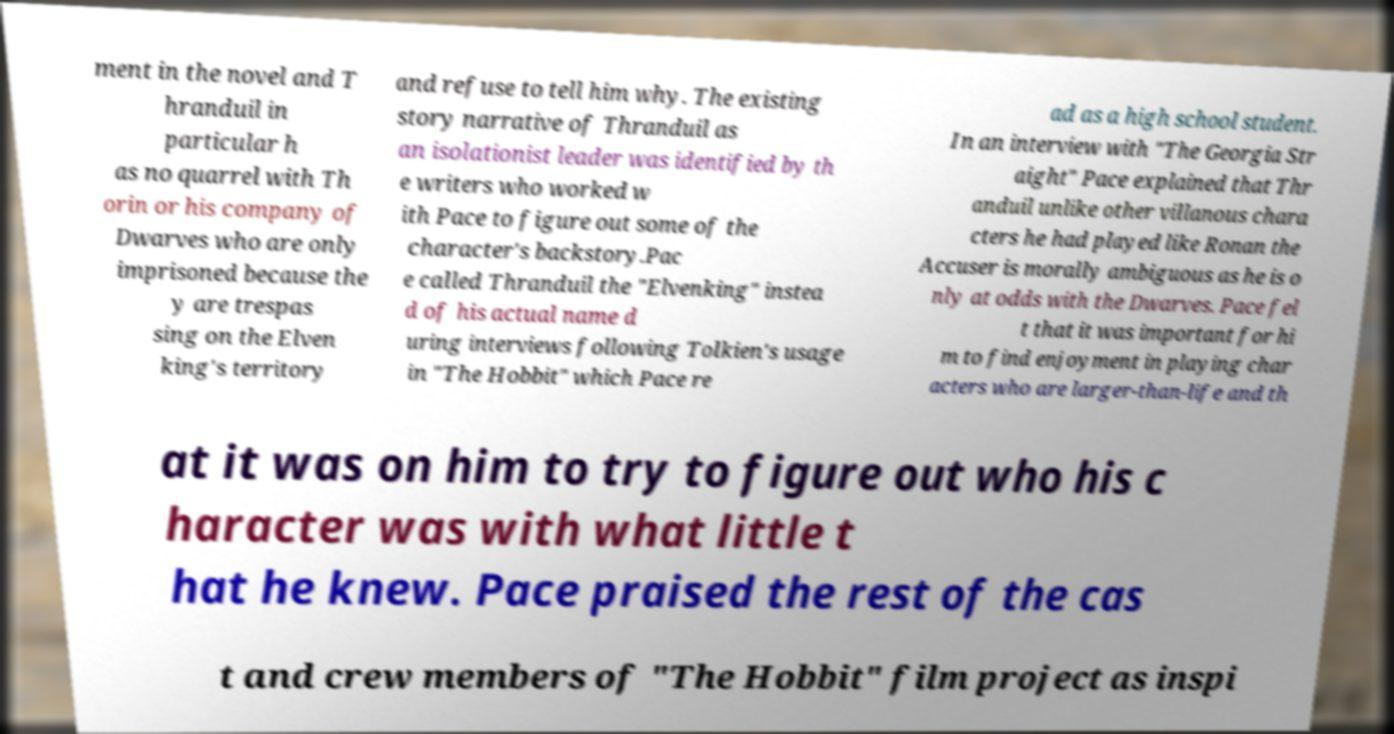For documentation purposes, I need the text within this image transcribed. Could you provide that? ment in the novel and T hranduil in particular h as no quarrel with Th orin or his company of Dwarves who are only imprisoned because the y are trespas sing on the Elven king's territory and refuse to tell him why. The existing story narrative of Thranduil as an isolationist leader was identified by th e writers who worked w ith Pace to figure out some of the character's backstory.Pac e called Thranduil the "Elvenking" instea d of his actual name d uring interviews following Tolkien's usage in "The Hobbit" which Pace re ad as a high school student. In an interview with "The Georgia Str aight" Pace explained that Thr anduil unlike other villanous chara cters he had played like Ronan the Accuser is morally ambiguous as he is o nly at odds with the Dwarves. Pace fel t that it was important for hi m to find enjoyment in playing char acters who are larger-than-life and th at it was on him to try to figure out who his c haracter was with what little t hat he knew. Pace praised the rest of the cas t and crew members of "The Hobbit" film project as inspi 